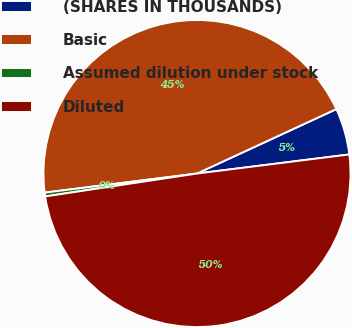Convert chart. <chart><loc_0><loc_0><loc_500><loc_500><pie_chart><fcel>(SHARES IN THOUSANDS)<fcel>Basic<fcel>Assumed dilution under stock<fcel>Diluted<nl><fcel>4.91%<fcel>45.09%<fcel>0.4%<fcel>49.6%<nl></chart> 